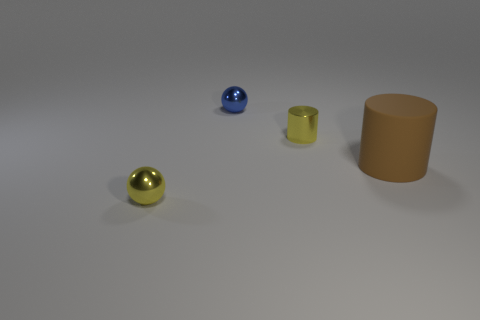What is the brown object made of?
Ensure brevity in your answer.  Rubber. Are there any green cylinders?
Give a very brief answer. No. Is the number of tiny yellow metallic things in front of the big rubber object the same as the number of big purple matte cylinders?
Give a very brief answer. No. Is there anything else that has the same material as the brown object?
Your answer should be very brief. No. What number of small objects are either blue metallic things or balls?
Offer a terse response. 2. What is the shape of the tiny shiny object that is the same color as the small cylinder?
Keep it short and to the point. Sphere. Is the material of the cylinder behind the big matte thing the same as the small yellow ball?
Your answer should be very brief. Yes. What material is the small ball behind the metallic object that is in front of the small cylinder?
Provide a short and direct response. Metal. What number of other big brown matte things have the same shape as the big matte object?
Offer a terse response. 0. What size is the metal ball behind the metal thing in front of the yellow object behind the matte cylinder?
Make the answer very short. Small. 